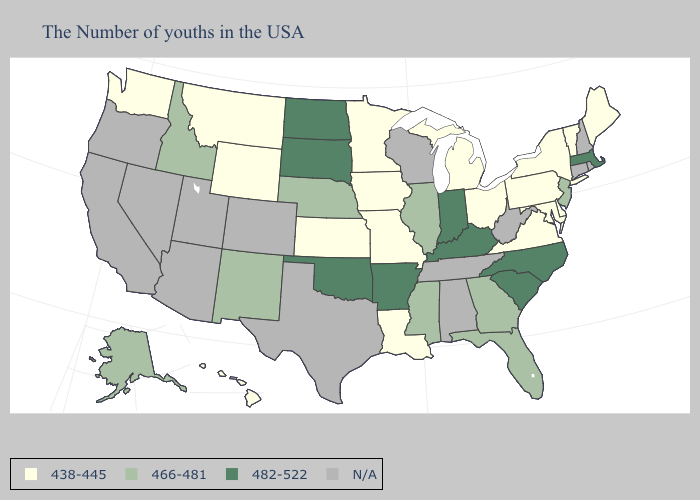What is the lowest value in the USA?
Short answer required. 438-445. Name the states that have a value in the range 482-522?
Be succinct. Massachusetts, North Carolina, South Carolina, Kentucky, Indiana, Arkansas, Oklahoma, South Dakota, North Dakota. Name the states that have a value in the range 438-445?
Concise answer only. Maine, Vermont, New York, Delaware, Maryland, Pennsylvania, Virginia, Ohio, Michigan, Louisiana, Missouri, Minnesota, Iowa, Kansas, Wyoming, Montana, Washington, Hawaii. Which states have the highest value in the USA?
Write a very short answer. Massachusetts, North Carolina, South Carolina, Kentucky, Indiana, Arkansas, Oklahoma, South Dakota, North Dakota. Does Oklahoma have the lowest value in the USA?
Give a very brief answer. No. Name the states that have a value in the range N/A?
Give a very brief answer. Rhode Island, New Hampshire, Connecticut, West Virginia, Alabama, Tennessee, Wisconsin, Texas, Colorado, Utah, Arizona, Nevada, California, Oregon. What is the value of Hawaii?
Write a very short answer. 438-445. What is the value of Kansas?
Short answer required. 438-445. What is the highest value in the USA?
Concise answer only. 482-522. Among the states that border Montana , does Idaho have the highest value?
Write a very short answer. No. Name the states that have a value in the range N/A?
Write a very short answer. Rhode Island, New Hampshire, Connecticut, West Virginia, Alabama, Tennessee, Wisconsin, Texas, Colorado, Utah, Arizona, Nevada, California, Oregon. Which states have the lowest value in the South?
Give a very brief answer. Delaware, Maryland, Virginia, Louisiana. Does Georgia have the lowest value in the USA?
Write a very short answer. No. Among the states that border Louisiana , which have the lowest value?
Give a very brief answer. Mississippi. 